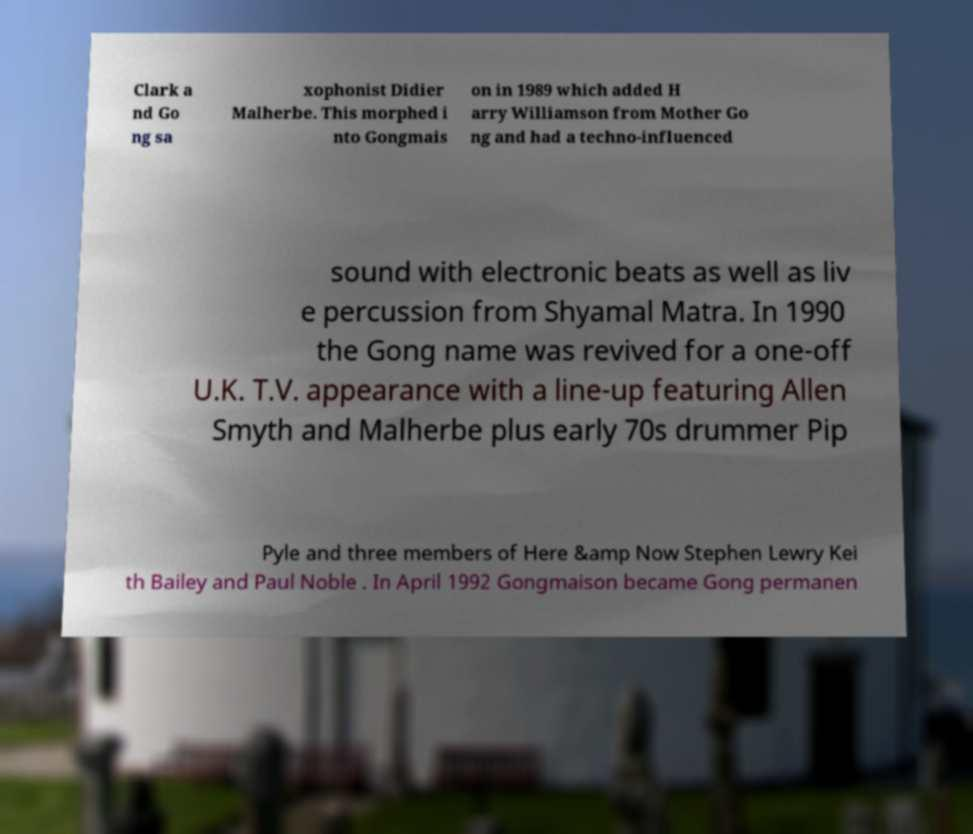There's text embedded in this image that I need extracted. Can you transcribe it verbatim? Clark a nd Go ng sa xophonist Didier Malherbe. This morphed i nto Gongmais on in 1989 which added H arry Williamson from Mother Go ng and had a techno-influenced sound with electronic beats as well as liv e percussion from Shyamal Matra. In 1990 the Gong name was revived for a one-off U.K. T.V. appearance with a line-up featuring Allen Smyth and Malherbe plus early 70s drummer Pip Pyle and three members of Here &amp Now Stephen Lewry Kei th Bailey and Paul Noble . In April 1992 Gongmaison became Gong permanen 